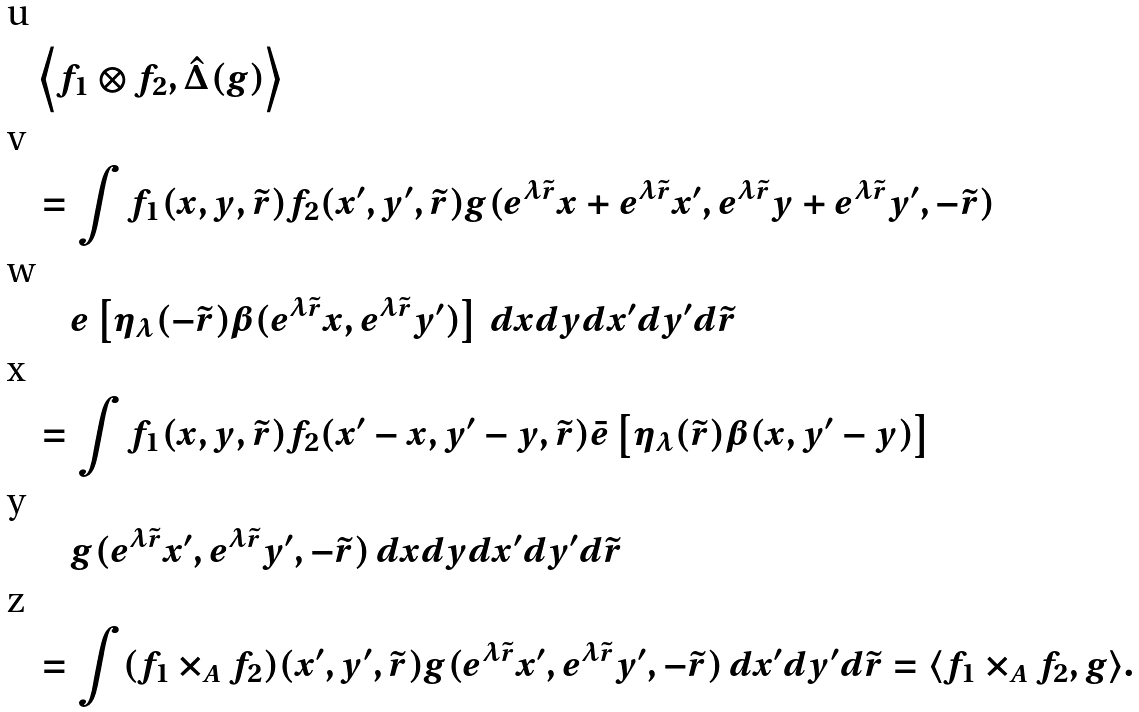Convert formula to latex. <formula><loc_0><loc_0><loc_500><loc_500>& \left \langle f _ { 1 } \otimes f _ { 2 } , \hat { \Delta } ( g ) \right \rangle \\ & = \int f _ { 1 } ( x , y , \tilde { r } ) f _ { 2 } ( x ^ { \prime } , y ^ { \prime } , \tilde { r } ) g ( e ^ { \lambda \tilde { r } } x + e ^ { \lambda \tilde { r } } x ^ { \prime } , e ^ { \lambda \tilde { r } } y + e ^ { \lambda \tilde { r } } y ^ { \prime } , - \tilde { r } ) \\ & \quad e \left [ \eta _ { \lambda } ( - \tilde { r } ) \beta ( e ^ { \lambda \tilde { r } } x , e ^ { \lambda \tilde { r } } y ^ { \prime } ) \right ] \, d x d y d x ^ { \prime } d y ^ { \prime } d \tilde { r } \\ & = \int f _ { 1 } ( x , y , \tilde { r } ) f _ { 2 } ( x ^ { \prime } - x , y ^ { \prime } - y , \tilde { r } ) \bar { e } \left [ \eta _ { \lambda } ( \tilde { r } ) \beta ( x , y ^ { \prime } - y ) \right ] \\ & \quad g ( e ^ { \lambda \tilde { r } } x ^ { \prime } , e ^ { \lambda \tilde { r } } y ^ { \prime } , - \tilde { r } ) \, d x d y d x ^ { \prime } d y ^ { \prime } d \tilde { r } \\ & = \int ( f _ { 1 } \times _ { A } f _ { 2 } ) ( x ^ { \prime } , y ^ { \prime } , \tilde { r } ) g ( e ^ { \lambda \tilde { r } } x ^ { \prime } , e ^ { \lambda \tilde { r } } y ^ { \prime } , - \tilde { r } ) \, d x ^ { \prime } d y ^ { \prime } d \tilde { r } = \langle f _ { 1 } \times _ { A } f _ { 2 } , g \rangle .</formula> 